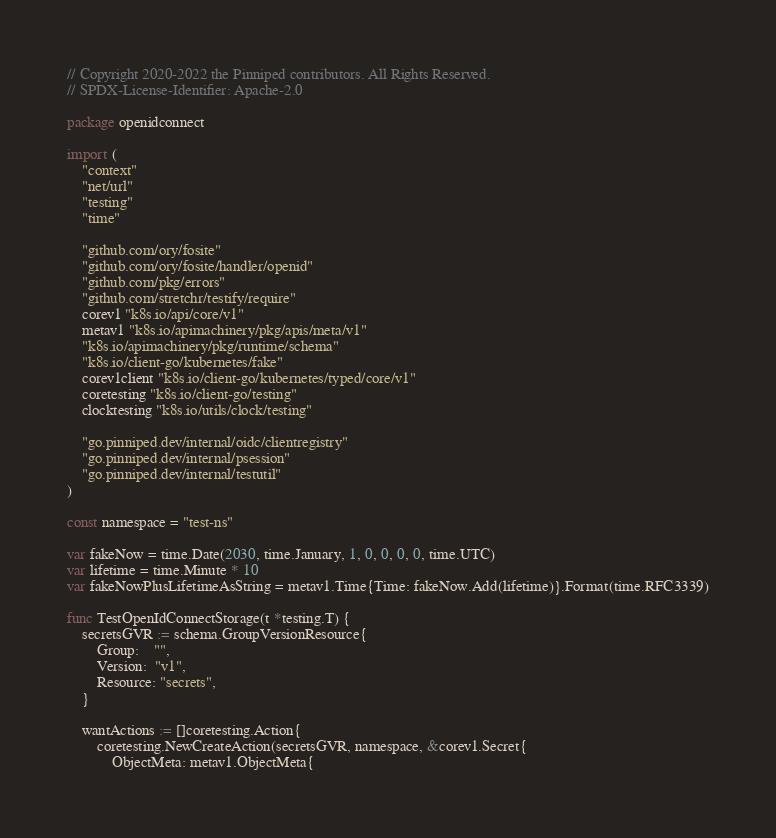Convert code to text. <code><loc_0><loc_0><loc_500><loc_500><_Go_>// Copyright 2020-2022 the Pinniped contributors. All Rights Reserved.
// SPDX-License-Identifier: Apache-2.0

package openidconnect

import (
	"context"
	"net/url"
	"testing"
	"time"

	"github.com/ory/fosite"
	"github.com/ory/fosite/handler/openid"
	"github.com/pkg/errors"
	"github.com/stretchr/testify/require"
	corev1 "k8s.io/api/core/v1"
	metav1 "k8s.io/apimachinery/pkg/apis/meta/v1"
	"k8s.io/apimachinery/pkg/runtime/schema"
	"k8s.io/client-go/kubernetes/fake"
	corev1client "k8s.io/client-go/kubernetes/typed/core/v1"
	coretesting "k8s.io/client-go/testing"
	clocktesting "k8s.io/utils/clock/testing"

	"go.pinniped.dev/internal/oidc/clientregistry"
	"go.pinniped.dev/internal/psession"
	"go.pinniped.dev/internal/testutil"
)

const namespace = "test-ns"

var fakeNow = time.Date(2030, time.January, 1, 0, 0, 0, 0, time.UTC)
var lifetime = time.Minute * 10
var fakeNowPlusLifetimeAsString = metav1.Time{Time: fakeNow.Add(lifetime)}.Format(time.RFC3339)

func TestOpenIdConnectStorage(t *testing.T) {
	secretsGVR := schema.GroupVersionResource{
		Group:    "",
		Version:  "v1",
		Resource: "secrets",
	}

	wantActions := []coretesting.Action{
		coretesting.NewCreateAction(secretsGVR, namespace, &corev1.Secret{
			ObjectMeta: metav1.ObjectMeta{</code> 